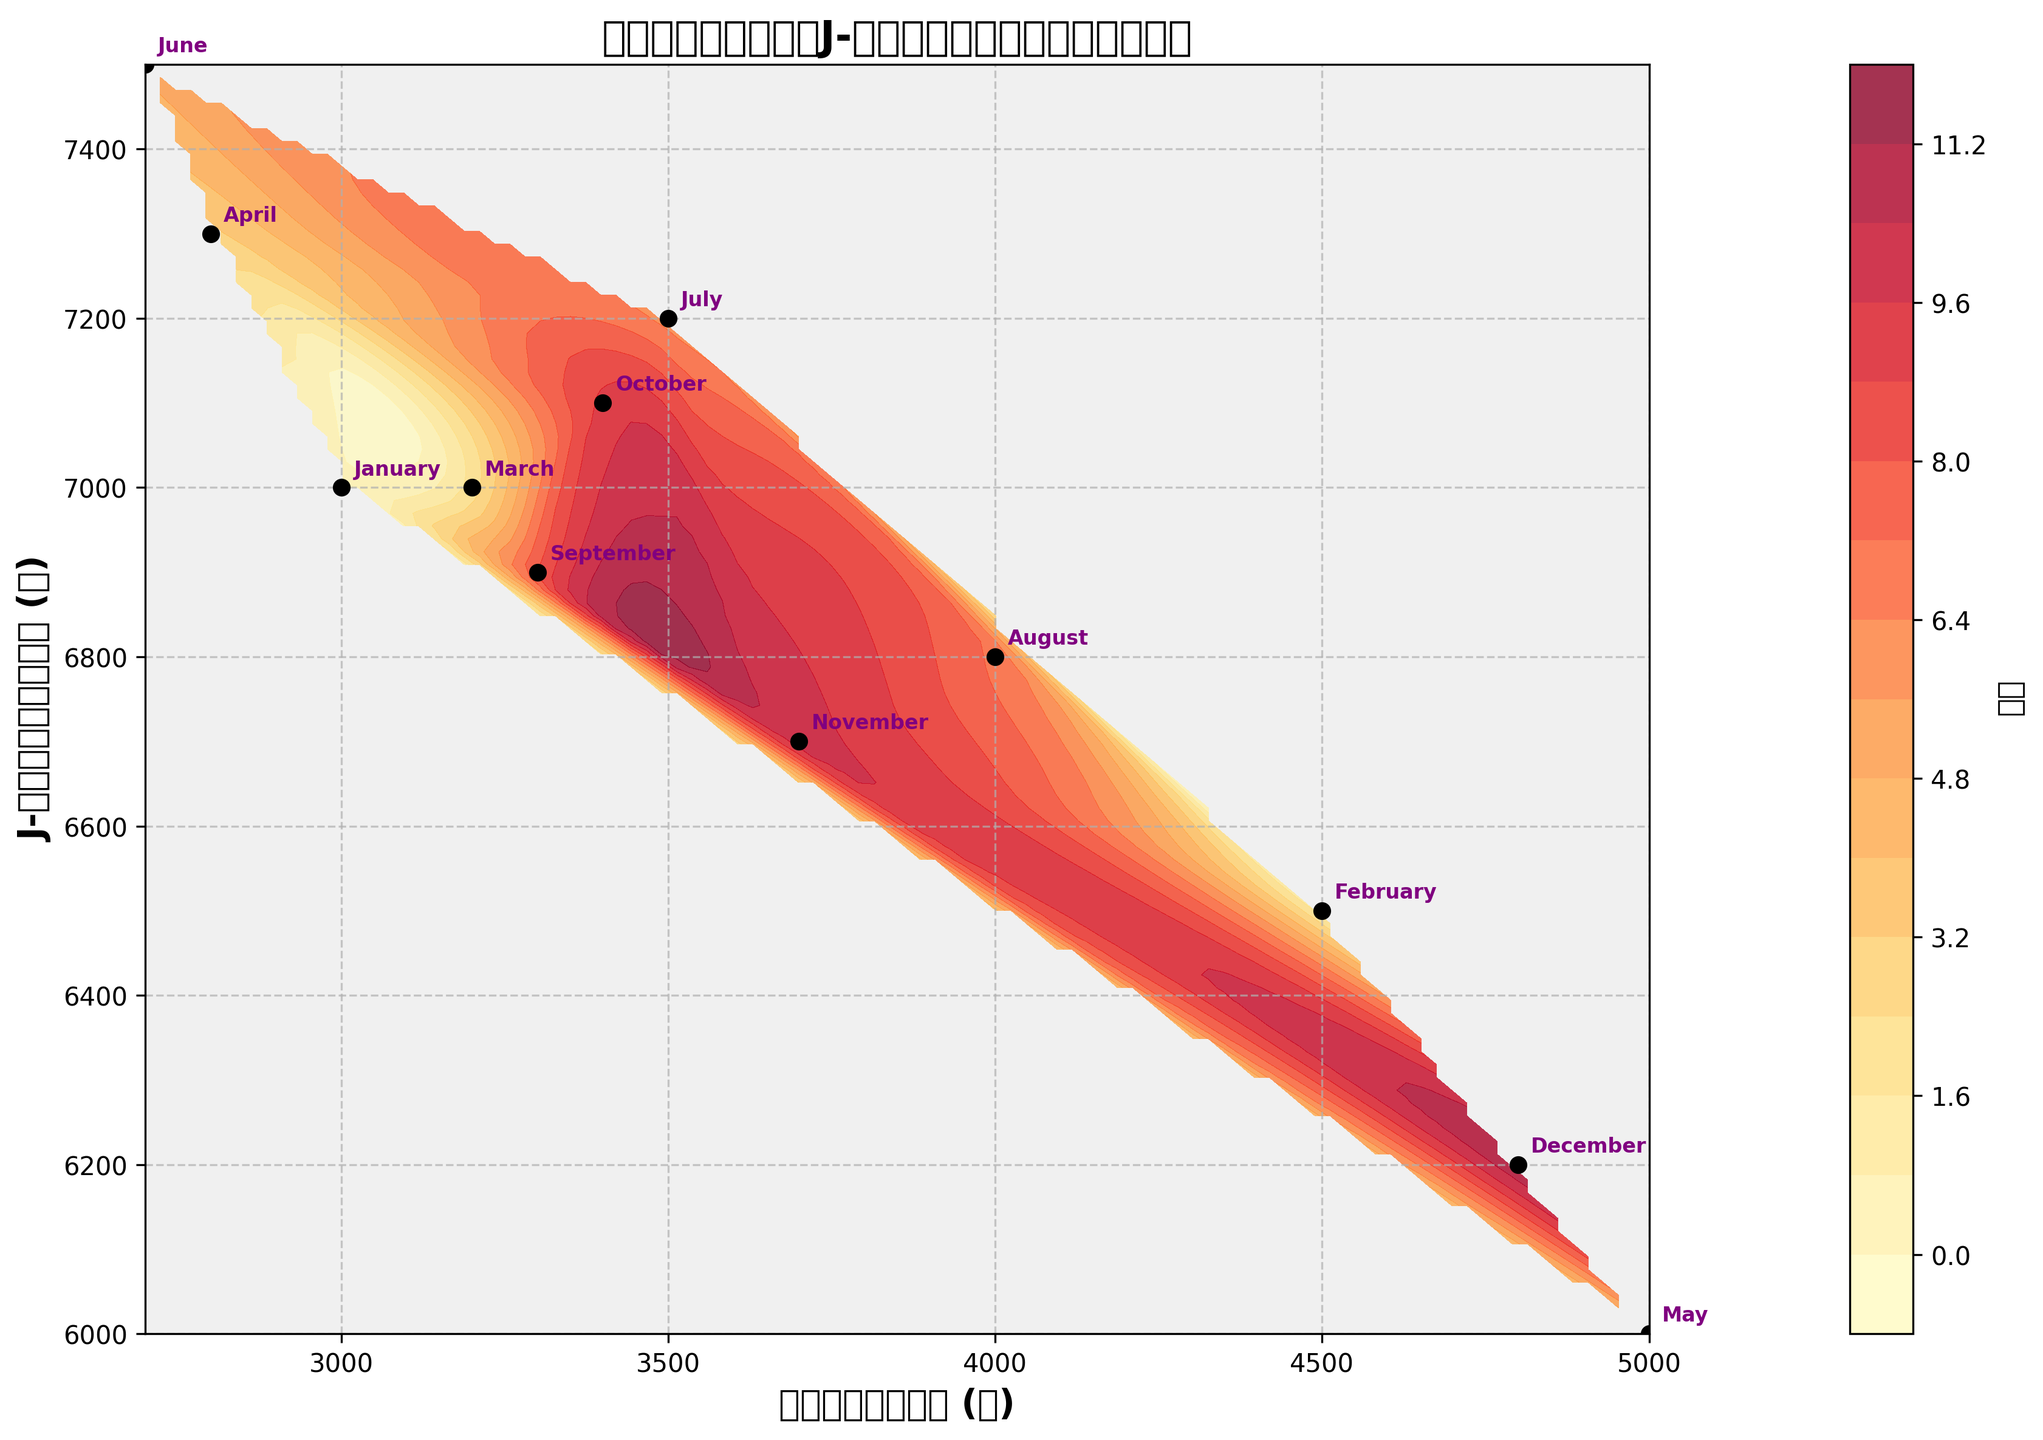what is the title of the plot? The title is presented directly at the top of the plot in bold font. It reads "月別アニメグッズとJ-ロックアルバムの支出パターン," which translates to "Monthly Anime Merchandise and J-Rock Album Spending Patterns."
Answer: 月別アニメグッズとJ-ロックアルバムの支出パターン What is the x-axis label? The x-axis label is located below the x-axis and indicates what the x-axis represents. It is "アニメグッズ支出 (円)," which means "Anime Merchandise Spending (JPY)."
Answer: アニメグッズ支出 (円) What month had the highest spending on anime merchandise? The spending can be observed by looking at the data points on the x-axis. The farthest right data point on the x-axis indicates the highest spending. In this case, the month with the highest spending is May (5000 JPY).
Answer: May Which month had the lowest spending on J-Rock Albums? The spending can be observed by looking at the data points on the y-axis. The lowest data point on the y-axis indicates the lowest spending. In this case, May is also the month with the lowest spending on J-Rock Albums (6000 JPY).
Answer: May What is the color representing the majority of areas on the plot? The majority of areas on the plot are filled with a light yellow color, which represents lower values of the contour levels. This color indicates the general trend of spending amounts.
Answer: light yellow How do the spending patterns on anime merchandise and J-Rock albums change between January and December? To understand the patterns, compare the positions of the data points marked for January and December. January shows (3000, 7000) and December shows (4800, 6200). The anime merchandise spending increased, while J-Rock album spending decreased.
Answer: Anime merchandise spending increased, J-Rock album spending decreased Which month's data points are closest together? By examining the distance between data points, March (3200, 7000) and April (2800, 7300) are closest to each other on the plot. This confirms the months are experiencing similar spending patterns.
Answer: March and April Combine the spending on anime merchandise and J-Rock albums for July. What is the total? To find the total spending, add the values from both axes for July. That is 3500 (anime merchandise) + 7200 (J-Rock albums) = 10700 JPY.
Answer: 10700 JPY Is there a month where the spending on anime merchandise and J-Rock albums is almost equal? By checking the plot, we can see that the closest spending values on both axes happen in August (4000, 6800). However, they are not equal. No month has spending amounts that are almost equal.
Answer: No In which month is the difference between anime merchandise and J-Rock album spending the largest? By calculating the difference for each month, October shows the largest difference (3700 units). This is the difference between 7100 (J-Rock albums) and 3400 (anime merchandise).
Answer: October 